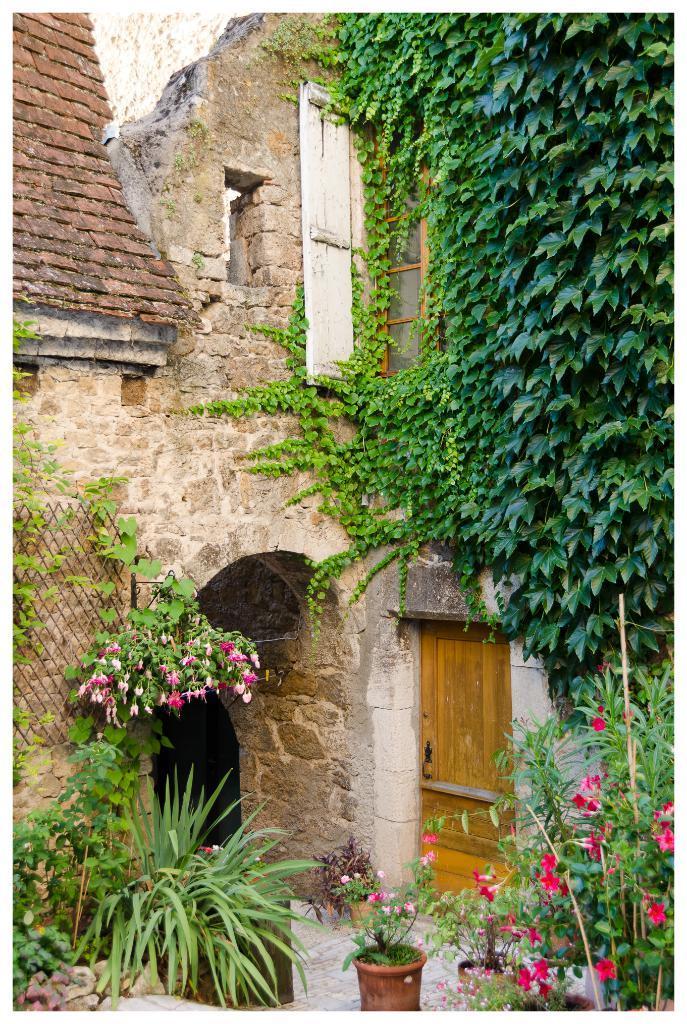Describe this image in one or two sentences. In the image there are plants and trees in front of an architecture. 